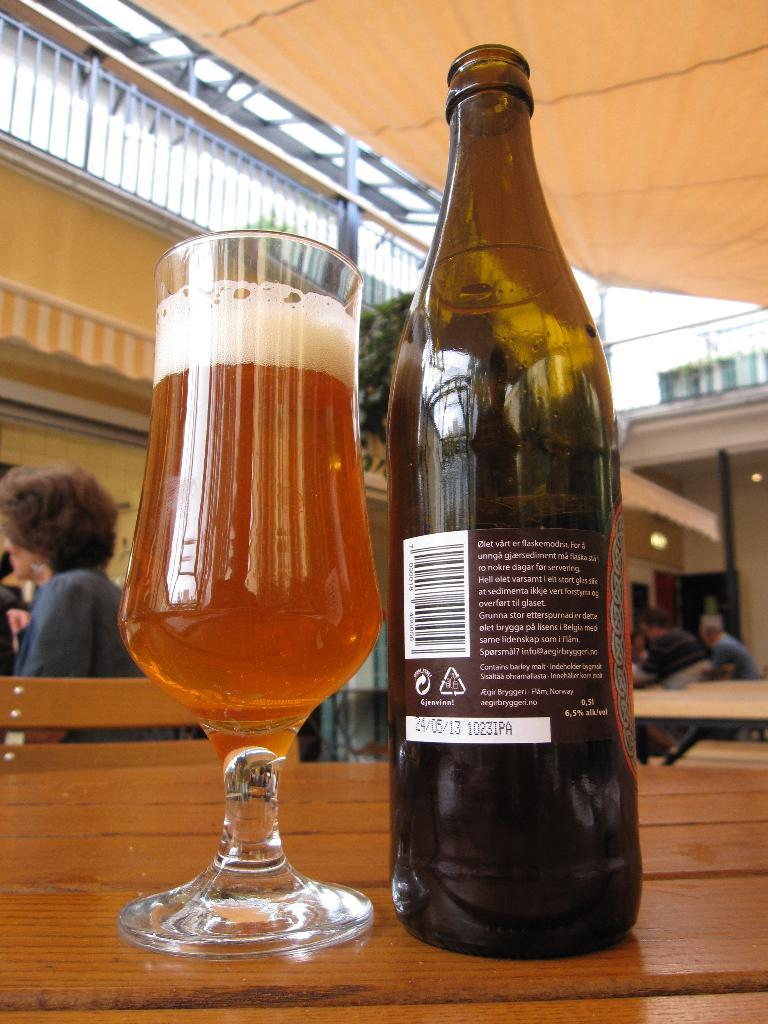<image>
Describe the image concisely. A mostly full lager glass sits on a table beside a bottle showing the reverse of a label with Danish text. 